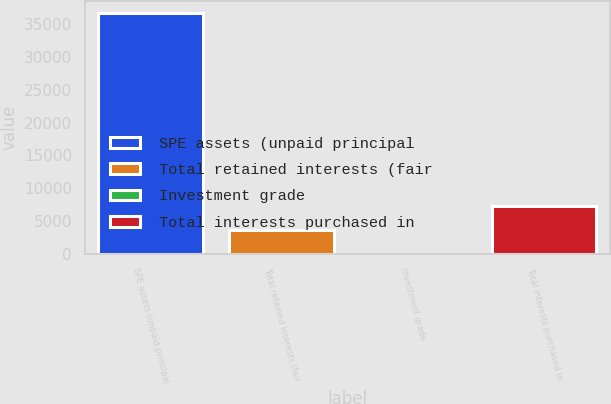Convert chart to OTSL. <chart><loc_0><loc_0><loc_500><loc_500><bar_chart><fcel>SPE assets (unpaid principal<fcel>Total retained interests (fair<fcel>Investment grade<fcel>Total interests purchased in<nl><fcel>36750<fcel>3684.9<fcel>11<fcel>7358.8<nl></chart> 